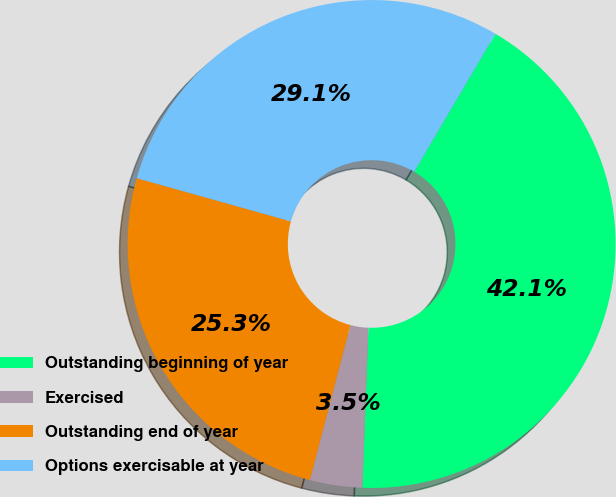Convert chart. <chart><loc_0><loc_0><loc_500><loc_500><pie_chart><fcel>Outstanding beginning of year<fcel>Exercised<fcel>Outstanding end of year<fcel>Options exercisable at year<nl><fcel>42.13%<fcel>3.47%<fcel>25.27%<fcel>29.13%<nl></chart> 